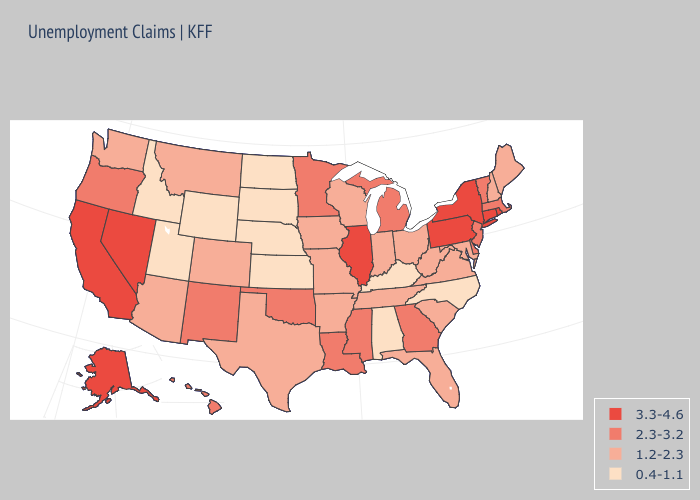What is the lowest value in states that border Nevada?
Answer briefly. 0.4-1.1. What is the value of Illinois?
Answer briefly. 3.3-4.6. Does Missouri have the highest value in the MidWest?
Quick response, please. No. What is the lowest value in the USA?
Answer briefly. 0.4-1.1. Name the states that have a value in the range 0.4-1.1?
Write a very short answer. Alabama, Idaho, Kansas, Kentucky, Nebraska, North Carolina, North Dakota, South Dakota, Utah, Wyoming. Name the states that have a value in the range 1.2-2.3?
Be succinct. Arizona, Arkansas, Colorado, Florida, Indiana, Iowa, Maine, Maryland, Missouri, Montana, New Hampshire, Ohio, South Carolina, Tennessee, Texas, Virginia, Washington, West Virginia, Wisconsin. Does South Carolina have a higher value than Oklahoma?
Short answer required. No. Name the states that have a value in the range 2.3-3.2?
Be succinct. Delaware, Georgia, Hawaii, Louisiana, Massachusetts, Michigan, Minnesota, Mississippi, New Jersey, New Mexico, Oklahoma, Oregon, Vermont. Among the states that border Montana , which have the highest value?
Answer briefly. Idaho, North Dakota, South Dakota, Wyoming. What is the value of New Jersey?
Be succinct. 2.3-3.2. Does the map have missing data?
Write a very short answer. No. Name the states that have a value in the range 0.4-1.1?
Short answer required. Alabama, Idaho, Kansas, Kentucky, Nebraska, North Carolina, North Dakota, South Dakota, Utah, Wyoming. Name the states that have a value in the range 0.4-1.1?
Write a very short answer. Alabama, Idaho, Kansas, Kentucky, Nebraska, North Carolina, North Dakota, South Dakota, Utah, Wyoming. What is the value of Michigan?
Keep it brief. 2.3-3.2. Which states have the lowest value in the USA?
Quick response, please. Alabama, Idaho, Kansas, Kentucky, Nebraska, North Carolina, North Dakota, South Dakota, Utah, Wyoming. 